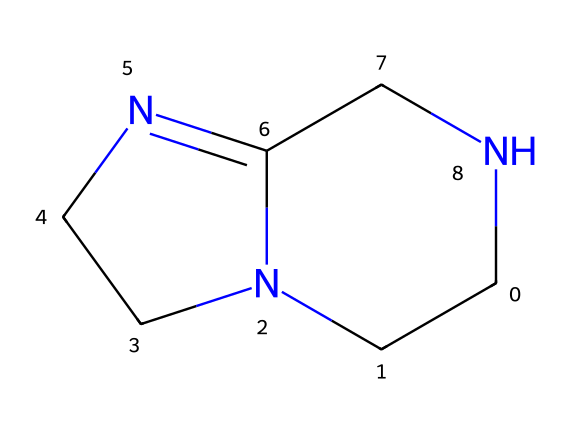What is the molecular formula of 1,5,7-triazabicyclo[4.4.0]dec-5-ene? By analyzing the SMILES representation, we can count the types and number of atoms. The structure contains 6 carbon atoms, 9 hydrogen atoms, and 3 nitrogen atoms, resulting in the molecular formula C6H9N3.
Answer: C6H9N3 How many nitrogen atoms are present in the structure? From the SMILES, we identify the nitrogen atoms denoted by 'N'. By counting, we find there are three nitrogen atoms in the structure.
Answer: 3 What type of compound is 1,5,7-triazabicyclo[4.4.0]dec-5-ene classified as? This compound contains multiple nitrogen atoms in a bicyclic structure which characterizes it as a superbase. Superbases are defined by their high basicity, closely linked to the presence of nitrogen in their structure.
Answer: superbase What type of hybridization is observed at the nitrogen atoms? In the structure, the nitrogen atoms are involved in bonding that suggests sp2 hybridization due to their planar arrangement and attachment to adjacent carbon atoms. This can be inferred by examining the bonding arrangement around the nitrogen.
Answer: sp2 What role does 1,5,7-triazabicyclo[4.4.0]dec-5-ene play in conductive polymers? The compound serves as a strong base which is key to deprotonating acidic components in conductive polymers, facilitating charge transport and enhancing conductivity. Its structure allows efficient interactions in the polymer matrix.
Answer: strong base 